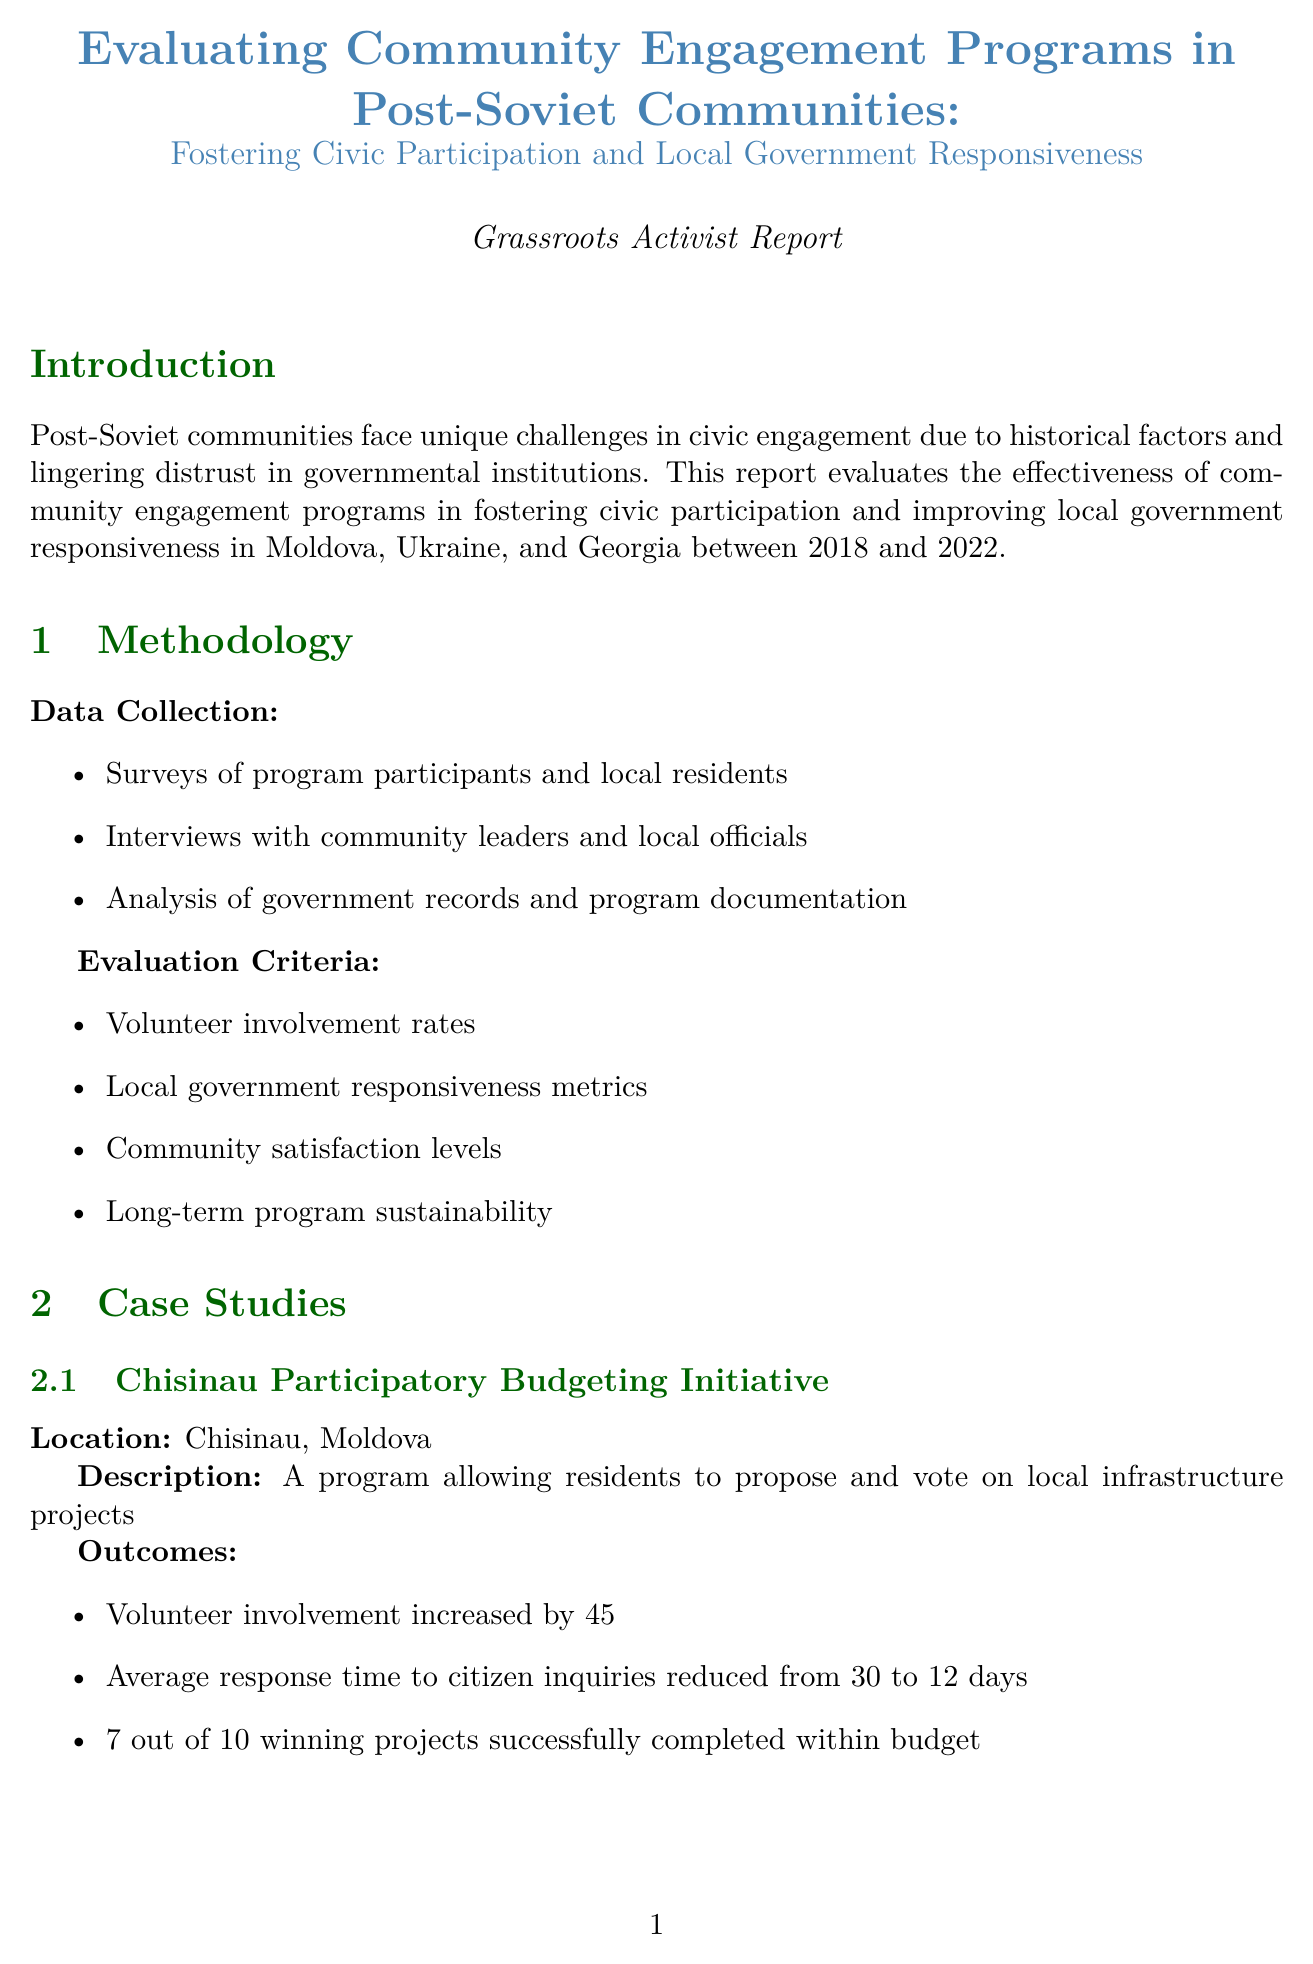What is the report title? The title provides the main subject of the evaluation report regarding community engagement in post-Soviet communities.
Answer: Evaluating Community Engagement Programs in Post-Soviet Communities: Fostering Civic Participation and Local Government Responsiveness Which countries are included in the study? The countries are specified in the introduction, showing the regions where community engagement programs were implemented.
Answer: Moldova, Ukraine, and Georgia What was the increase in volunteer involvement in the Chisinau initiative? This outcome showcases the impact of the participatory budgeting initiative on community involvement over the two-year period.
Answer: Increased by 45% over two years What was the voter turnout in Tbilisi's council elections? This statistic reflects community engagement and political participation levels in Tbilisi before and after the program implementation.
Answer: 32% How many active users did the Lviv Digital Democracy Platform attract within the first year? This number provides insight into the platform's reach and engagement level within the community.
Answer: 20,000 active users What was the average response time to citizen inquiries in the Chisinau program? This metric indicates the improvement in government responsiveness as a result of the program's implementation.
Answer: Reduced from 30 to 12 days What were the challenges mentioned in the report? The report highlights significant barriers that may hinder the effectiveness of community engagement programs in certain areas.
Answer: Language barriers, limited internet access, skepticism, long-term commitment What is one of the future focuses mentioned in the conclusion? This indicates the direction for subsequent efforts to enhance civic participation and government responsiveness.
Answer: Scaling successful programs to broader regions 